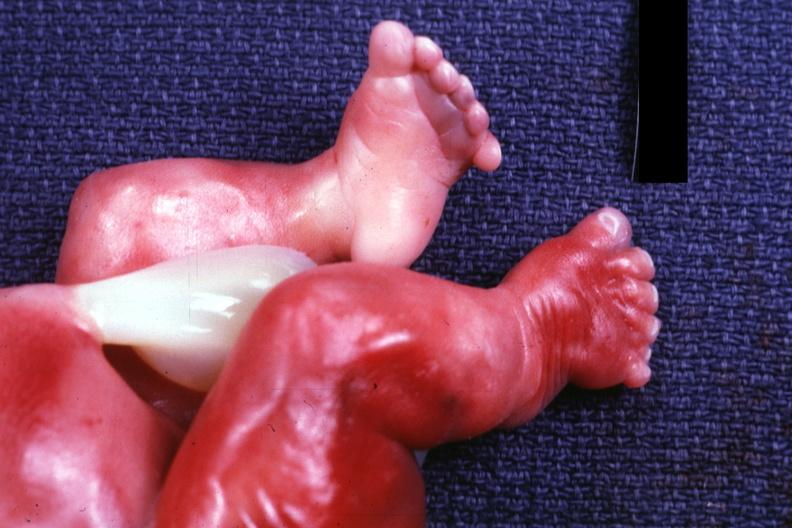what are too short?
Answer the question using a single word or phrase. Renal polycystic disease legs 